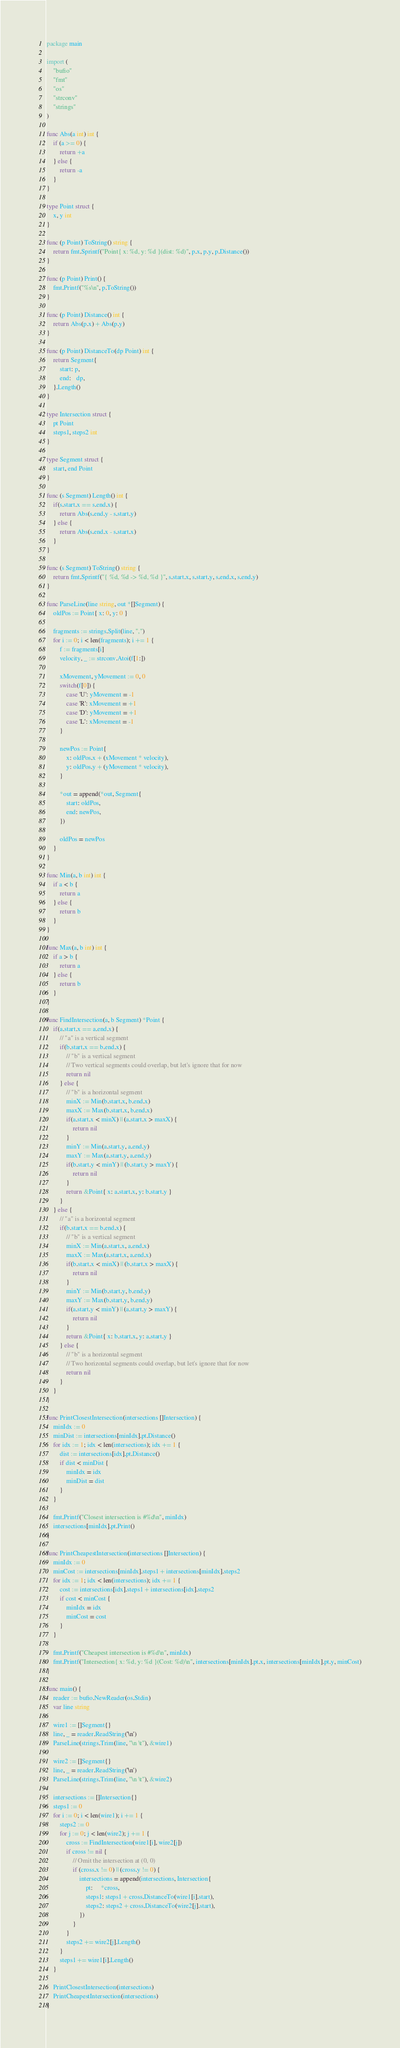<code> <loc_0><loc_0><loc_500><loc_500><_Go_>package main

import (
	"bufio"
	"fmt"
	"os"
	"strconv"
	"strings"
)

func Abs(a int) int {
	if (a >= 0) {
		return +a
	} else {
		return -a
	}
}

type Point struct {
	x, y int
}

func (p Point) ToString() string {
	return fmt.Sprintf("Point{ x: %d, y: %d }(dist: %d)", p.x, p.y, p.Distance())
}

func (p Point) Print() {
	fmt.Printf("%s\n", p.ToString())
}

func (p Point) Distance() int {
	return Abs(p.x) + Abs(p.y)
}

func (p Point) DistanceTo(dp Point) int {
	return Segment{
		start: p,
		end:   dp,
	}.Length()
}

type Intersection struct {
	pt Point
	steps1, steps2 int
}

type Segment struct {
	start, end Point
}

func (s Segment) Length() int {
	if(s.start.x == s.end.x) {
		return Abs(s.end.y - s.start.y)
	} else {
		return Abs(s.end.x - s.start.x)
	}
}

func (s Segment) ToString() string {
	return fmt.Sprintf("{ %d, %d -> %d, %d }", s.start.x, s.start.y, s.end.x, s.end.y)
}

func ParseLine(line string, out *[]Segment) {
	oldPos := Point{ x: 0, y: 0 }

	fragments := strings.Split(line, ",")
	for i := 0; i < len(fragments); i += 1 {
		f := fragments[i]
		velocity, _ := strconv.Atoi(f[1:])

		xMovement, yMovement := 0, 0
		switch(f[0]) {
			case 'U': yMovement = -1
			case 'R': xMovement = +1
			case 'D': yMovement = +1
			case 'L': xMovement = -1
		}

		newPos := Point{
			x: oldPos.x + (xMovement * velocity),
			y: oldPos.y + (yMovement * velocity),
		}

		*out = append(*out, Segment{
			start: oldPos,
			end: newPos,
		})

		oldPos = newPos
	}
}

func Min(a, b int) int {
	if a < b {
		return a
	} else {
		return b
	}
}

func Max(a, b int) int {
	if a > b {
		return a
	} else {
		return b
	}
}

func FindIntersection(a, b Segment) *Point {
	if(a.start.x == a.end.x) {
		// "a" is a vertical segment
		if(b.start.x == b.end.x) {
			// "b" is a vertical segment
			// Two vertical segments could overlap, but let's ignore that for now
			return nil
		} else {
			// "b" is a horizontal segment
			minX := Min(b.start.x, b.end.x)
			maxX := Max(b.start.x, b.end.x)
			if(a.start.x < minX) || (a.start.x > maxX) {
				return nil
			}
			minY := Min(a.start.y, a.end.y)
			maxY := Max(a.start.y, a.end.y)
			if(b.start.y < minY) || (b.start.y > maxY) {
				return nil
			}
			return &Point{ x: a.start.x, y: b.start.y }
		}
	} else {
		// "a" is a horizontal segment
		if(b.start.x == b.end.x) {
			// "b" is a vertical segment
			minX := Min(a.start.x, a.end.x)
			maxX := Max(a.start.x, a.end.x)
			if(b.start.x < minX) || (b.start.x > maxX) {
				return nil
			}
			minY := Min(b.start.y, b.end.y)
			maxY := Max(b.start.y, b.end.y)
			if(a.start.y < minY) || (a.start.y > maxY) {
				return nil
			}
			return &Point{ x: b.start.x, y: a.start.y }
		} else {
			// "b" is a horizontal segment
			// Two horizontal segments could overlap, but let's ignore that for now
			return nil
		}
	}
}

func PrintClosestIntersection(intersections []Intersection) {
	minIdx := 0
	minDist := intersections[minIdx].pt.Distance()
	for idx := 1; idx < len(intersections); idx += 1 {
		dist := intersections[idx].pt.Distance()
		if dist < minDist {
			minIdx = idx
			minDist = dist
		}
	}

	fmt.Printf("Closest intersection is #%d\n", minIdx)
	intersections[minIdx].pt.Print()
}

func PrintCheapestIntersection(intersections []Intersection) {
	minIdx := 0
	minCost := intersections[minIdx].steps1 + intersections[minIdx].steps2
	for idx := 1; idx < len(intersections); idx += 1 {
		cost := intersections[idx].steps1 + intersections[idx].steps2
		if cost < minCost {
			minIdx = idx
			minCost = cost
		}
	}

	fmt.Printf("Cheapest intersection is #%d\n", minIdx)
	fmt.Printf("Intersection{ x: %d, y: %d }(Cost: %d)\n", intersections[minIdx].pt.x, intersections[minIdx].pt.y, minCost)
}

func main() {
	reader := bufio.NewReader(os.Stdin)
	var line string

	wire1 := []Segment{}
	line, _ = reader.ReadString('\n')
	ParseLine(strings.Trim(line, "\n \t"), &wire1)

	wire2 := []Segment{}
	line, _ = reader.ReadString('\n')
	ParseLine(strings.Trim(line, "\n \t"), &wire2)

	intersections := []Intersection{}
	steps1 := 0
	for i := 0; i < len(wire1); i += 1 {
		steps2 := 0
		for j := 0; j < len(wire2); j += 1 {
			cross := FindIntersection(wire1[i], wire2[j])
			if cross != nil {
				// Omit the intersection at (0, 0)
				if (cross.x != 0) || (cross.y != 0) {
					intersections = append(intersections, Intersection{
						pt:     *cross,
						steps1: steps1 + cross.DistanceTo(wire1[i].start),
						steps2: steps2 + cross.DistanceTo(wire2[j].start),
					})
				}
			}
			steps2 += wire2[j].Length()
		}
		steps1 += wire1[i].Length()
	}

	PrintClosestIntersection(intersections)
	PrintCheapestIntersection(intersections)
}</code> 